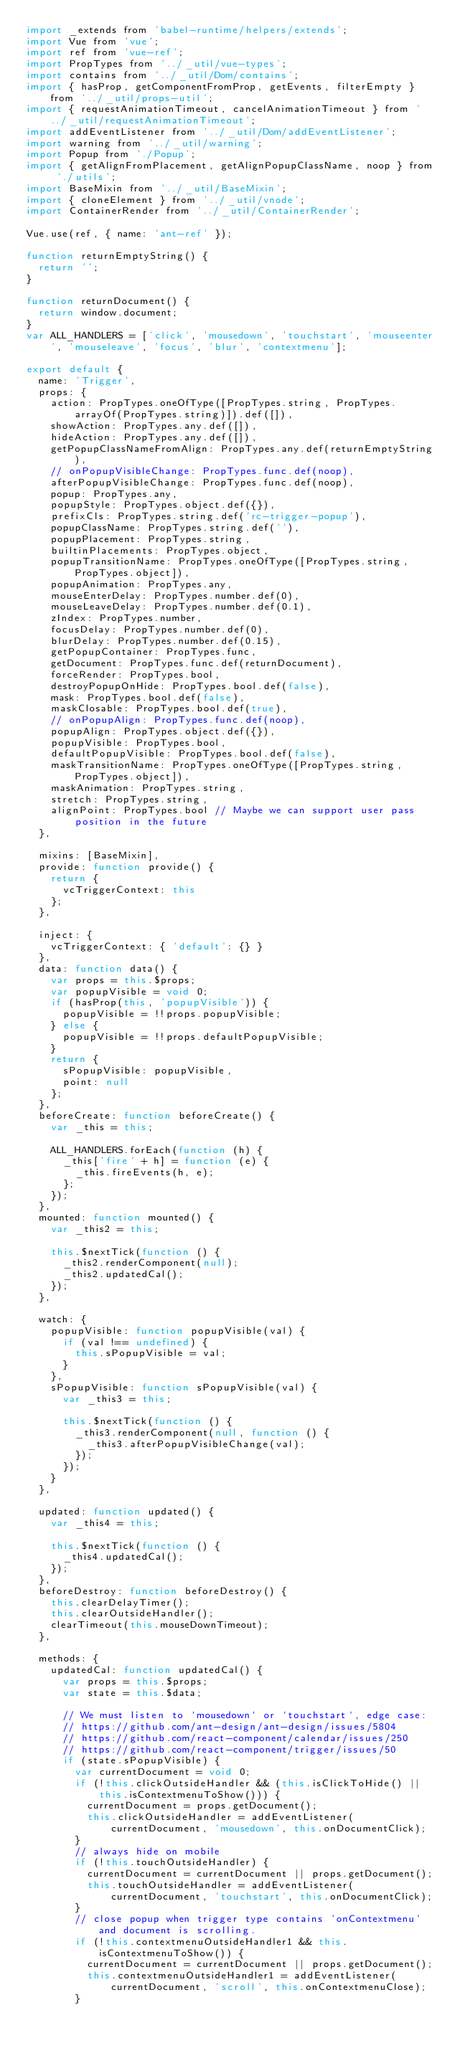<code> <loc_0><loc_0><loc_500><loc_500><_JavaScript_>import _extends from 'babel-runtime/helpers/extends';
import Vue from 'vue';
import ref from 'vue-ref';
import PropTypes from '../_util/vue-types';
import contains from '../_util/Dom/contains';
import { hasProp, getComponentFromProp, getEvents, filterEmpty } from '../_util/props-util';
import { requestAnimationTimeout, cancelAnimationTimeout } from '../_util/requestAnimationTimeout';
import addEventListener from '../_util/Dom/addEventListener';
import warning from '../_util/warning';
import Popup from './Popup';
import { getAlignFromPlacement, getAlignPopupClassName, noop } from './utils';
import BaseMixin from '../_util/BaseMixin';
import { cloneElement } from '../_util/vnode';
import ContainerRender from '../_util/ContainerRender';

Vue.use(ref, { name: 'ant-ref' });

function returnEmptyString() {
  return '';
}

function returnDocument() {
  return window.document;
}
var ALL_HANDLERS = ['click', 'mousedown', 'touchstart', 'mouseenter', 'mouseleave', 'focus', 'blur', 'contextmenu'];

export default {
  name: 'Trigger',
  props: {
    action: PropTypes.oneOfType([PropTypes.string, PropTypes.arrayOf(PropTypes.string)]).def([]),
    showAction: PropTypes.any.def([]),
    hideAction: PropTypes.any.def([]),
    getPopupClassNameFromAlign: PropTypes.any.def(returnEmptyString),
    // onPopupVisibleChange: PropTypes.func.def(noop),
    afterPopupVisibleChange: PropTypes.func.def(noop),
    popup: PropTypes.any,
    popupStyle: PropTypes.object.def({}),
    prefixCls: PropTypes.string.def('rc-trigger-popup'),
    popupClassName: PropTypes.string.def(''),
    popupPlacement: PropTypes.string,
    builtinPlacements: PropTypes.object,
    popupTransitionName: PropTypes.oneOfType([PropTypes.string, PropTypes.object]),
    popupAnimation: PropTypes.any,
    mouseEnterDelay: PropTypes.number.def(0),
    mouseLeaveDelay: PropTypes.number.def(0.1),
    zIndex: PropTypes.number,
    focusDelay: PropTypes.number.def(0),
    blurDelay: PropTypes.number.def(0.15),
    getPopupContainer: PropTypes.func,
    getDocument: PropTypes.func.def(returnDocument),
    forceRender: PropTypes.bool,
    destroyPopupOnHide: PropTypes.bool.def(false),
    mask: PropTypes.bool.def(false),
    maskClosable: PropTypes.bool.def(true),
    // onPopupAlign: PropTypes.func.def(noop),
    popupAlign: PropTypes.object.def({}),
    popupVisible: PropTypes.bool,
    defaultPopupVisible: PropTypes.bool.def(false),
    maskTransitionName: PropTypes.oneOfType([PropTypes.string, PropTypes.object]),
    maskAnimation: PropTypes.string,
    stretch: PropTypes.string,
    alignPoint: PropTypes.bool // Maybe we can support user pass position in the future
  },

  mixins: [BaseMixin],
  provide: function provide() {
    return {
      vcTriggerContext: this
    };
  },

  inject: {
    vcTriggerContext: { 'default': {} }
  },
  data: function data() {
    var props = this.$props;
    var popupVisible = void 0;
    if (hasProp(this, 'popupVisible')) {
      popupVisible = !!props.popupVisible;
    } else {
      popupVisible = !!props.defaultPopupVisible;
    }
    return {
      sPopupVisible: popupVisible,
      point: null
    };
  },
  beforeCreate: function beforeCreate() {
    var _this = this;

    ALL_HANDLERS.forEach(function (h) {
      _this['fire' + h] = function (e) {
        _this.fireEvents(h, e);
      };
    });
  },
  mounted: function mounted() {
    var _this2 = this;

    this.$nextTick(function () {
      _this2.renderComponent(null);
      _this2.updatedCal();
    });
  },

  watch: {
    popupVisible: function popupVisible(val) {
      if (val !== undefined) {
        this.sPopupVisible = val;
      }
    },
    sPopupVisible: function sPopupVisible(val) {
      var _this3 = this;

      this.$nextTick(function () {
        _this3.renderComponent(null, function () {
          _this3.afterPopupVisibleChange(val);
        });
      });
    }
  },

  updated: function updated() {
    var _this4 = this;

    this.$nextTick(function () {
      _this4.updatedCal();
    });
  },
  beforeDestroy: function beforeDestroy() {
    this.clearDelayTimer();
    this.clearOutsideHandler();
    clearTimeout(this.mouseDownTimeout);
  },

  methods: {
    updatedCal: function updatedCal() {
      var props = this.$props;
      var state = this.$data;

      // We must listen to `mousedown` or `touchstart`, edge case:
      // https://github.com/ant-design/ant-design/issues/5804
      // https://github.com/react-component/calendar/issues/250
      // https://github.com/react-component/trigger/issues/50
      if (state.sPopupVisible) {
        var currentDocument = void 0;
        if (!this.clickOutsideHandler && (this.isClickToHide() || this.isContextmenuToShow())) {
          currentDocument = props.getDocument();
          this.clickOutsideHandler = addEventListener(currentDocument, 'mousedown', this.onDocumentClick);
        }
        // always hide on mobile
        if (!this.touchOutsideHandler) {
          currentDocument = currentDocument || props.getDocument();
          this.touchOutsideHandler = addEventListener(currentDocument, 'touchstart', this.onDocumentClick);
        }
        // close popup when trigger type contains 'onContextmenu' and document is scrolling.
        if (!this.contextmenuOutsideHandler1 && this.isContextmenuToShow()) {
          currentDocument = currentDocument || props.getDocument();
          this.contextmenuOutsideHandler1 = addEventListener(currentDocument, 'scroll', this.onContextmenuClose);
        }</code> 